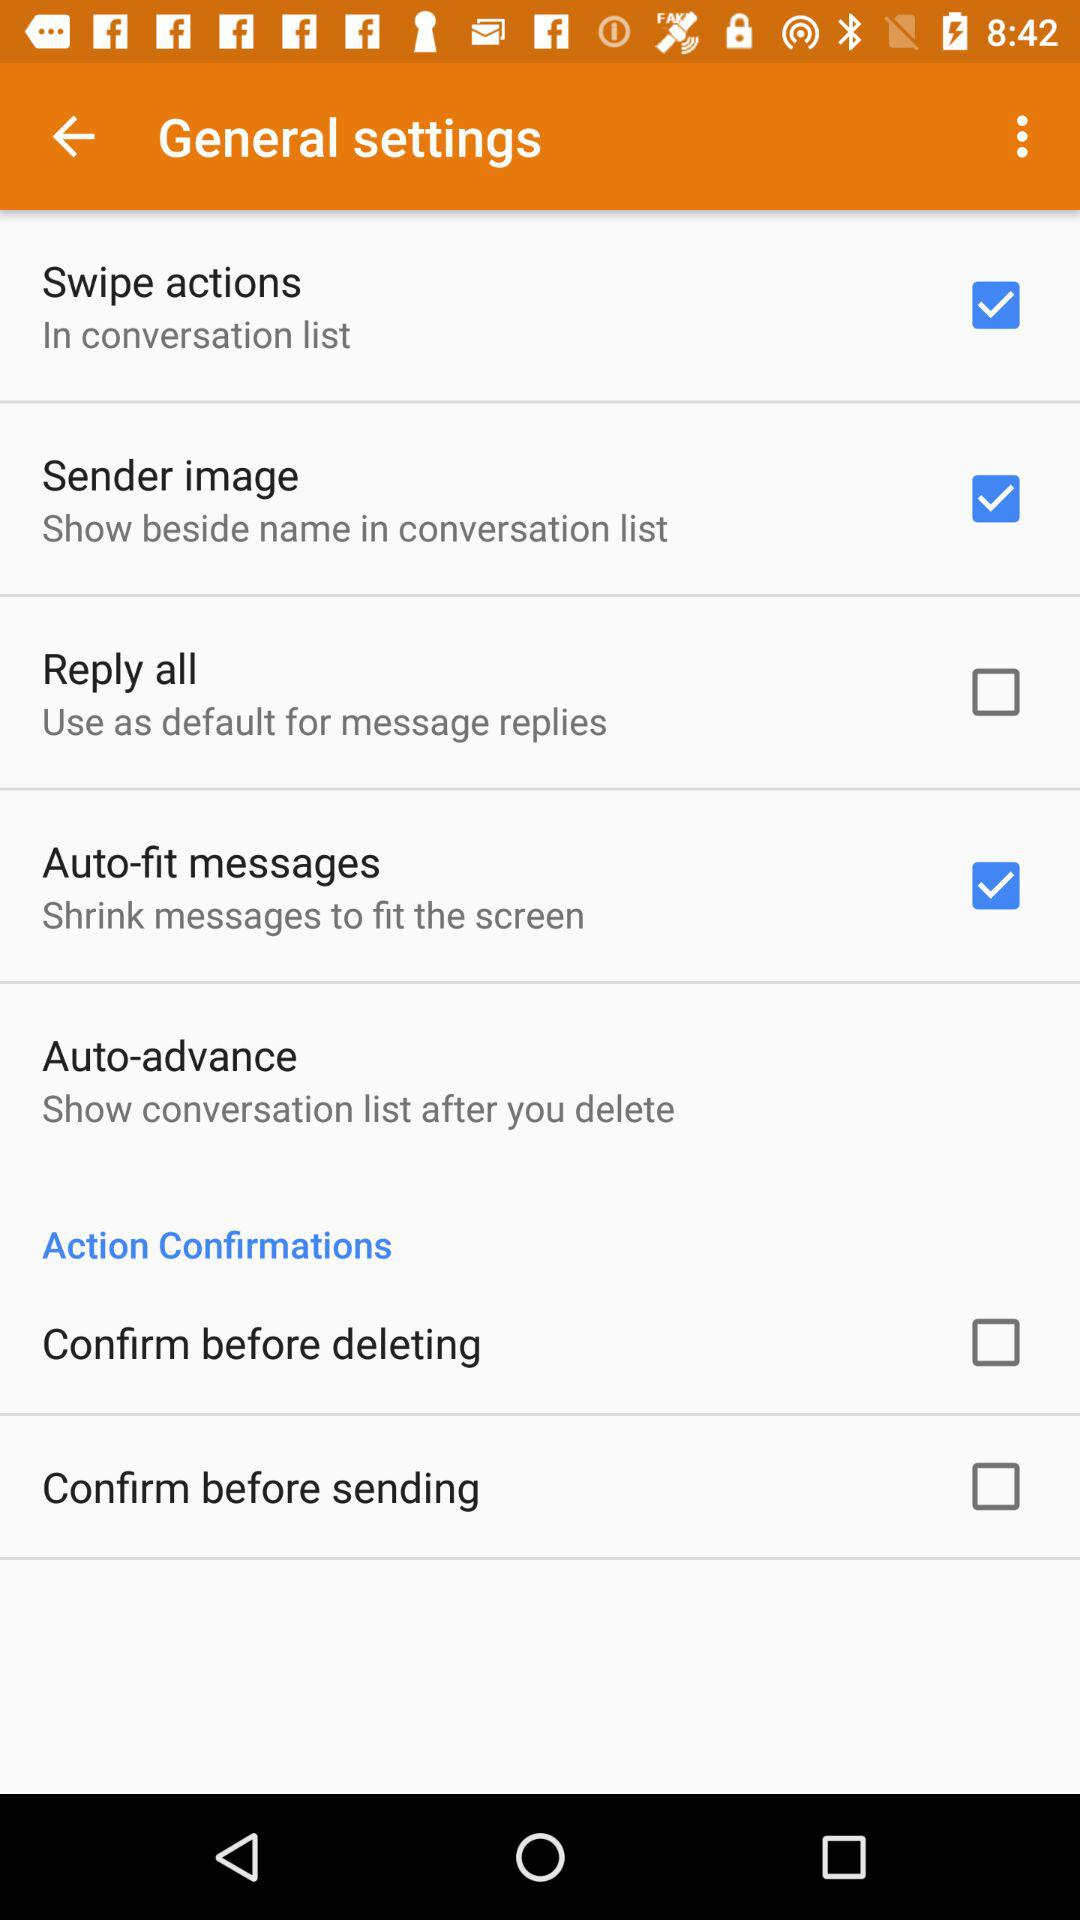What is the status of the "Confirm before sending"? The status is "off". 